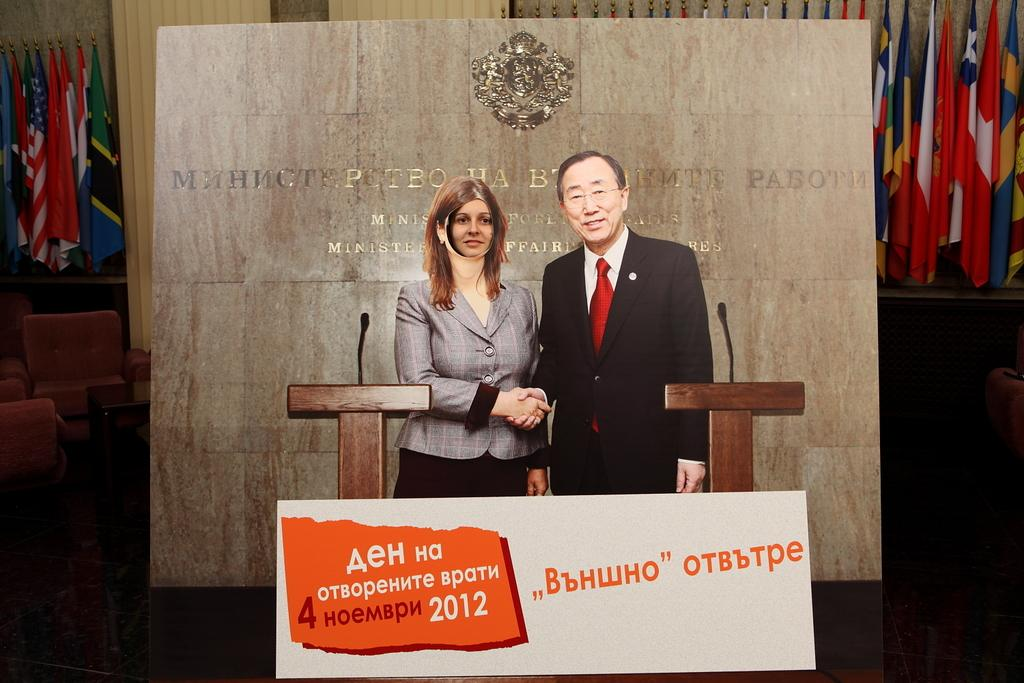How many people are in the image? There are two persons in the image. What can be seen in the image besides the people? There is text visible in the image, as well as a podium in the middle, flags in the background, and chairs on the left side. What type of zephyr is blowing in the middle of the image? There is no zephyr present in the image; it is a term for a gentle breeze, and there is no indication of wind or weather in the image. 